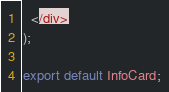<code> <loc_0><loc_0><loc_500><loc_500><_TypeScript_>  </div>
);

export default InfoCard;
</code> 